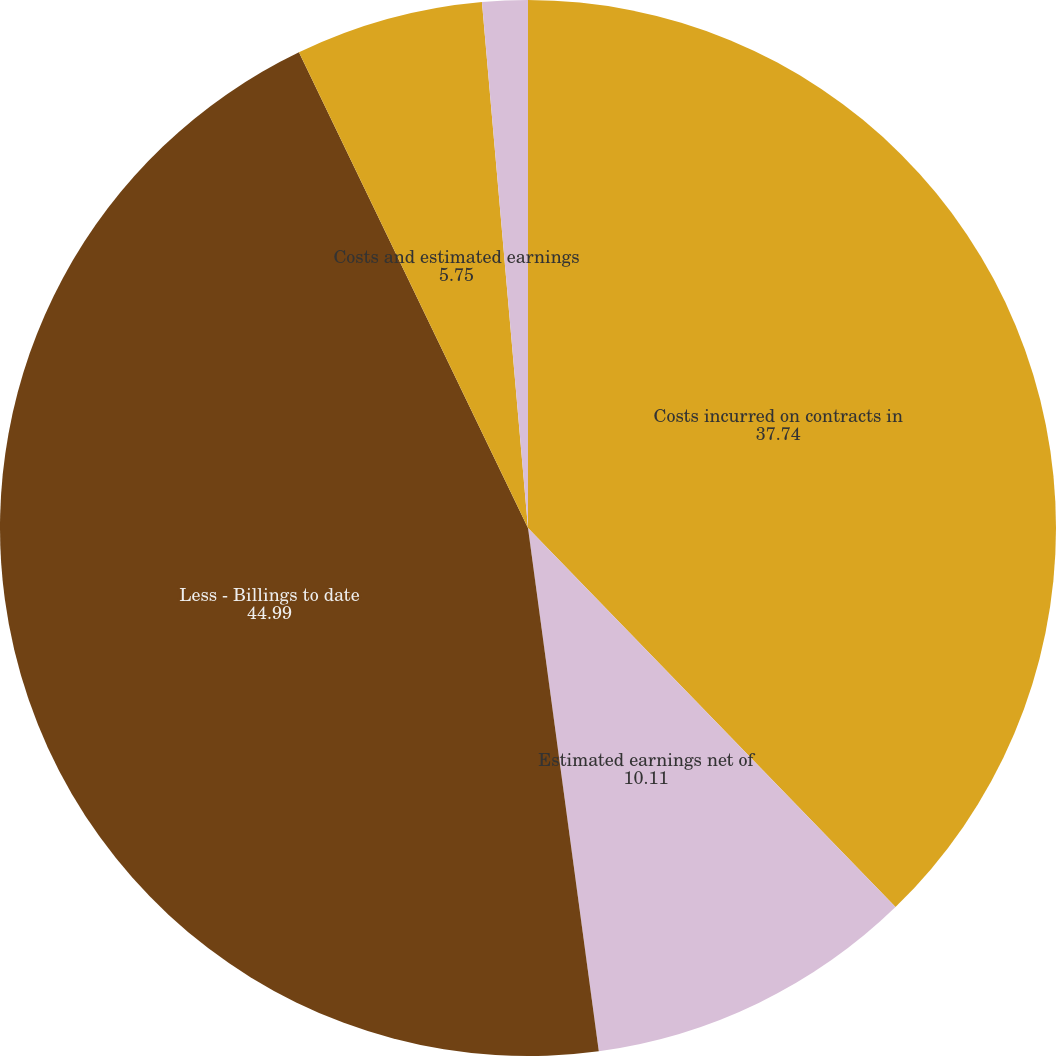<chart> <loc_0><loc_0><loc_500><loc_500><pie_chart><fcel>Costs incurred on contracts in<fcel>Estimated earnings net of<fcel>Less - Billings to date<fcel>Costs and estimated earnings<fcel>Less - Billings in excess of<nl><fcel>37.74%<fcel>10.11%<fcel>44.99%<fcel>5.75%<fcel>1.39%<nl></chart> 